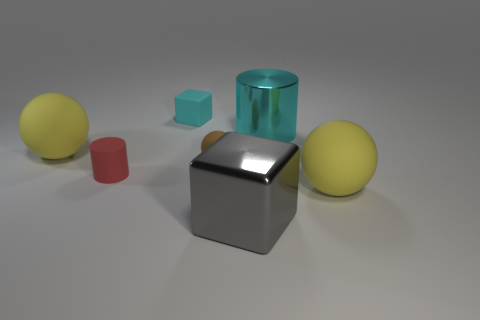Add 1 big rubber spheres. How many objects exist? 8 Subtract all balls. How many objects are left? 4 Add 1 tiny brown matte things. How many tiny brown matte things are left? 2 Add 4 large brown balls. How many large brown balls exist? 4 Subtract 0 blue balls. How many objects are left? 7 Subtract all purple cylinders. Subtract all big gray metallic cubes. How many objects are left? 6 